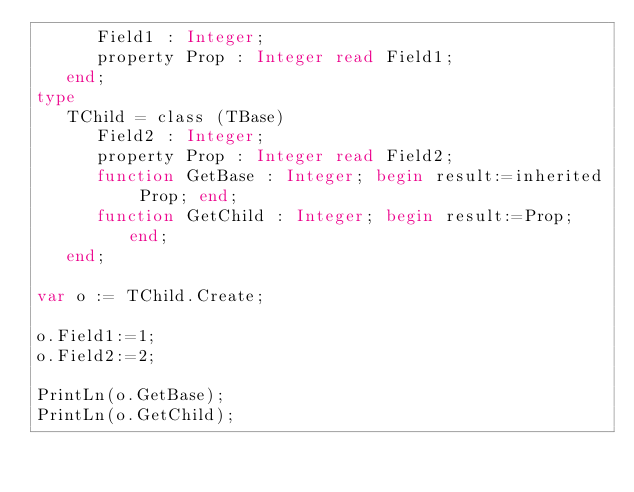<code> <loc_0><loc_0><loc_500><loc_500><_Pascal_>      Field1 : Integer;
      property Prop : Integer read Field1;
   end;
type
   TChild = class (TBase)
      Field2 : Integer;
      property Prop : Integer read Field2;
      function GetBase : Integer; begin result:=inherited Prop; end;
      function GetChild : Integer; begin result:=Prop; end;
   end;

var o := TChild.Create;

o.Field1:=1;
o.Field2:=2;

PrintLn(o.GetBase);
PrintLn(o.GetChild);
</code> 